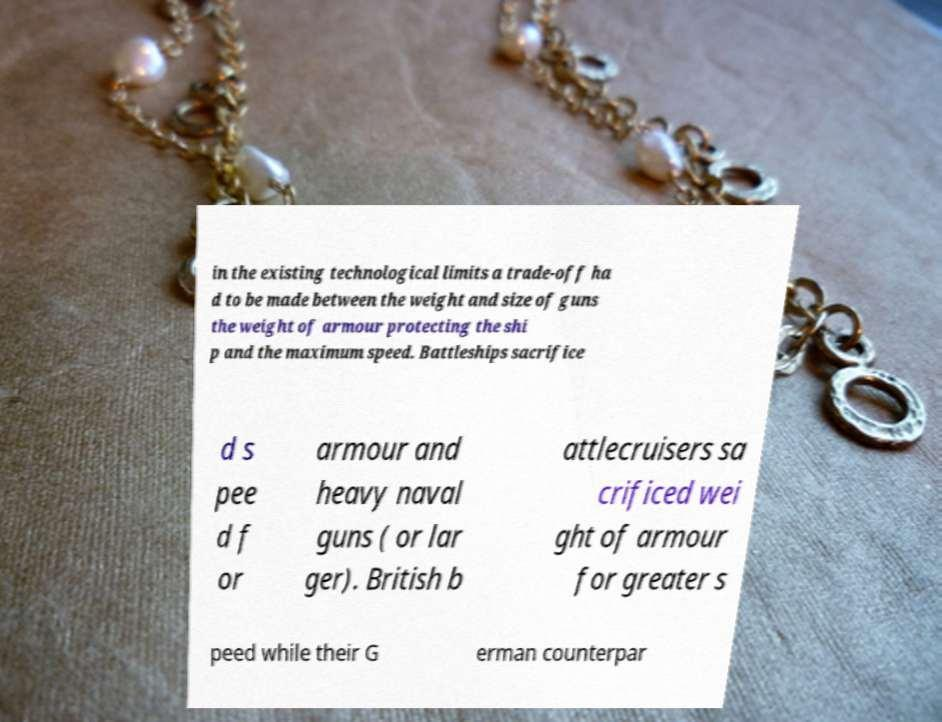I need the written content from this picture converted into text. Can you do that? in the existing technological limits a trade-off ha d to be made between the weight and size of guns the weight of armour protecting the shi p and the maximum speed. Battleships sacrifice d s pee d f or armour and heavy naval guns ( or lar ger). British b attlecruisers sa crificed wei ght of armour for greater s peed while their G erman counterpar 